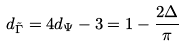Convert formula to latex. <formula><loc_0><loc_0><loc_500><loc_500>d _ { \tilde { \Gamma } } = 4 d _ { \Psi } - 3 = 1 - \frac { 2 \Delta } { \pi }</formula> 